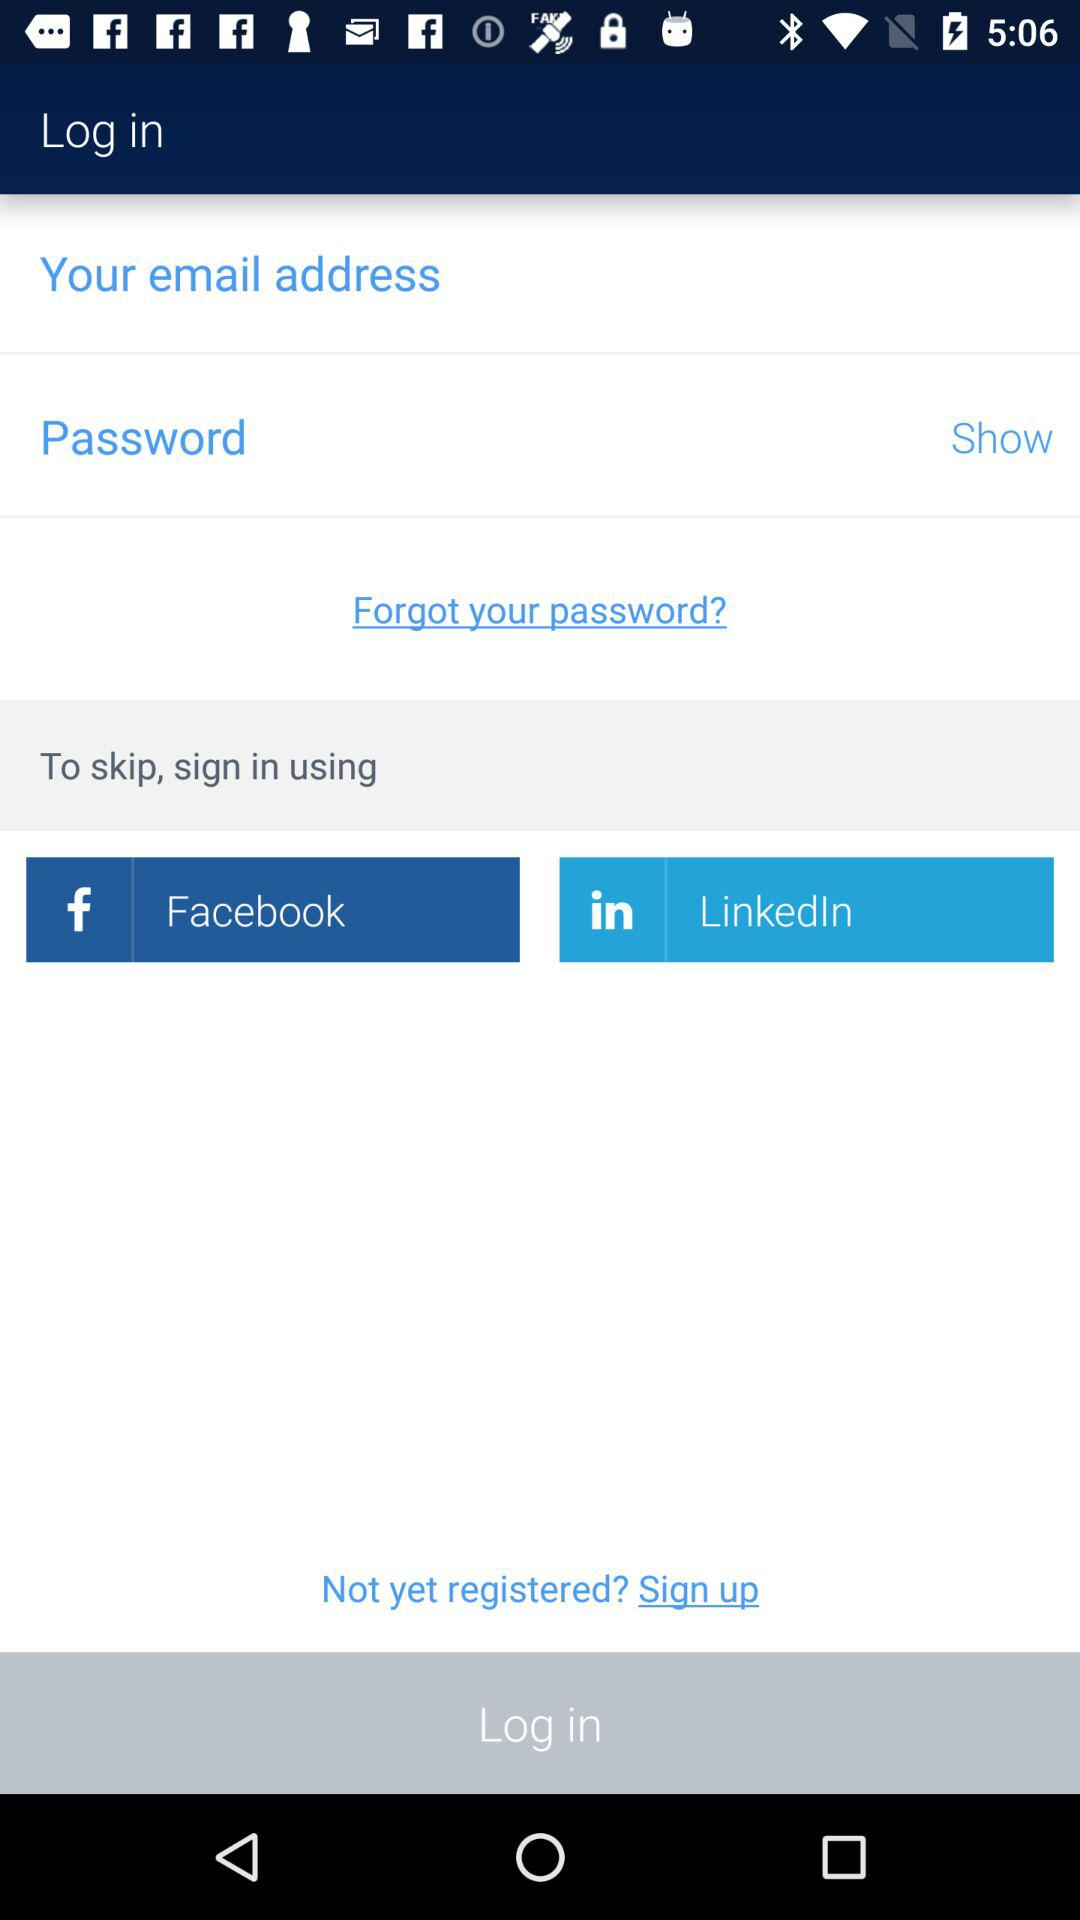What social apps can we use to sign in? The social apps that can be used to sign in are Facebook and LinkedIn. 